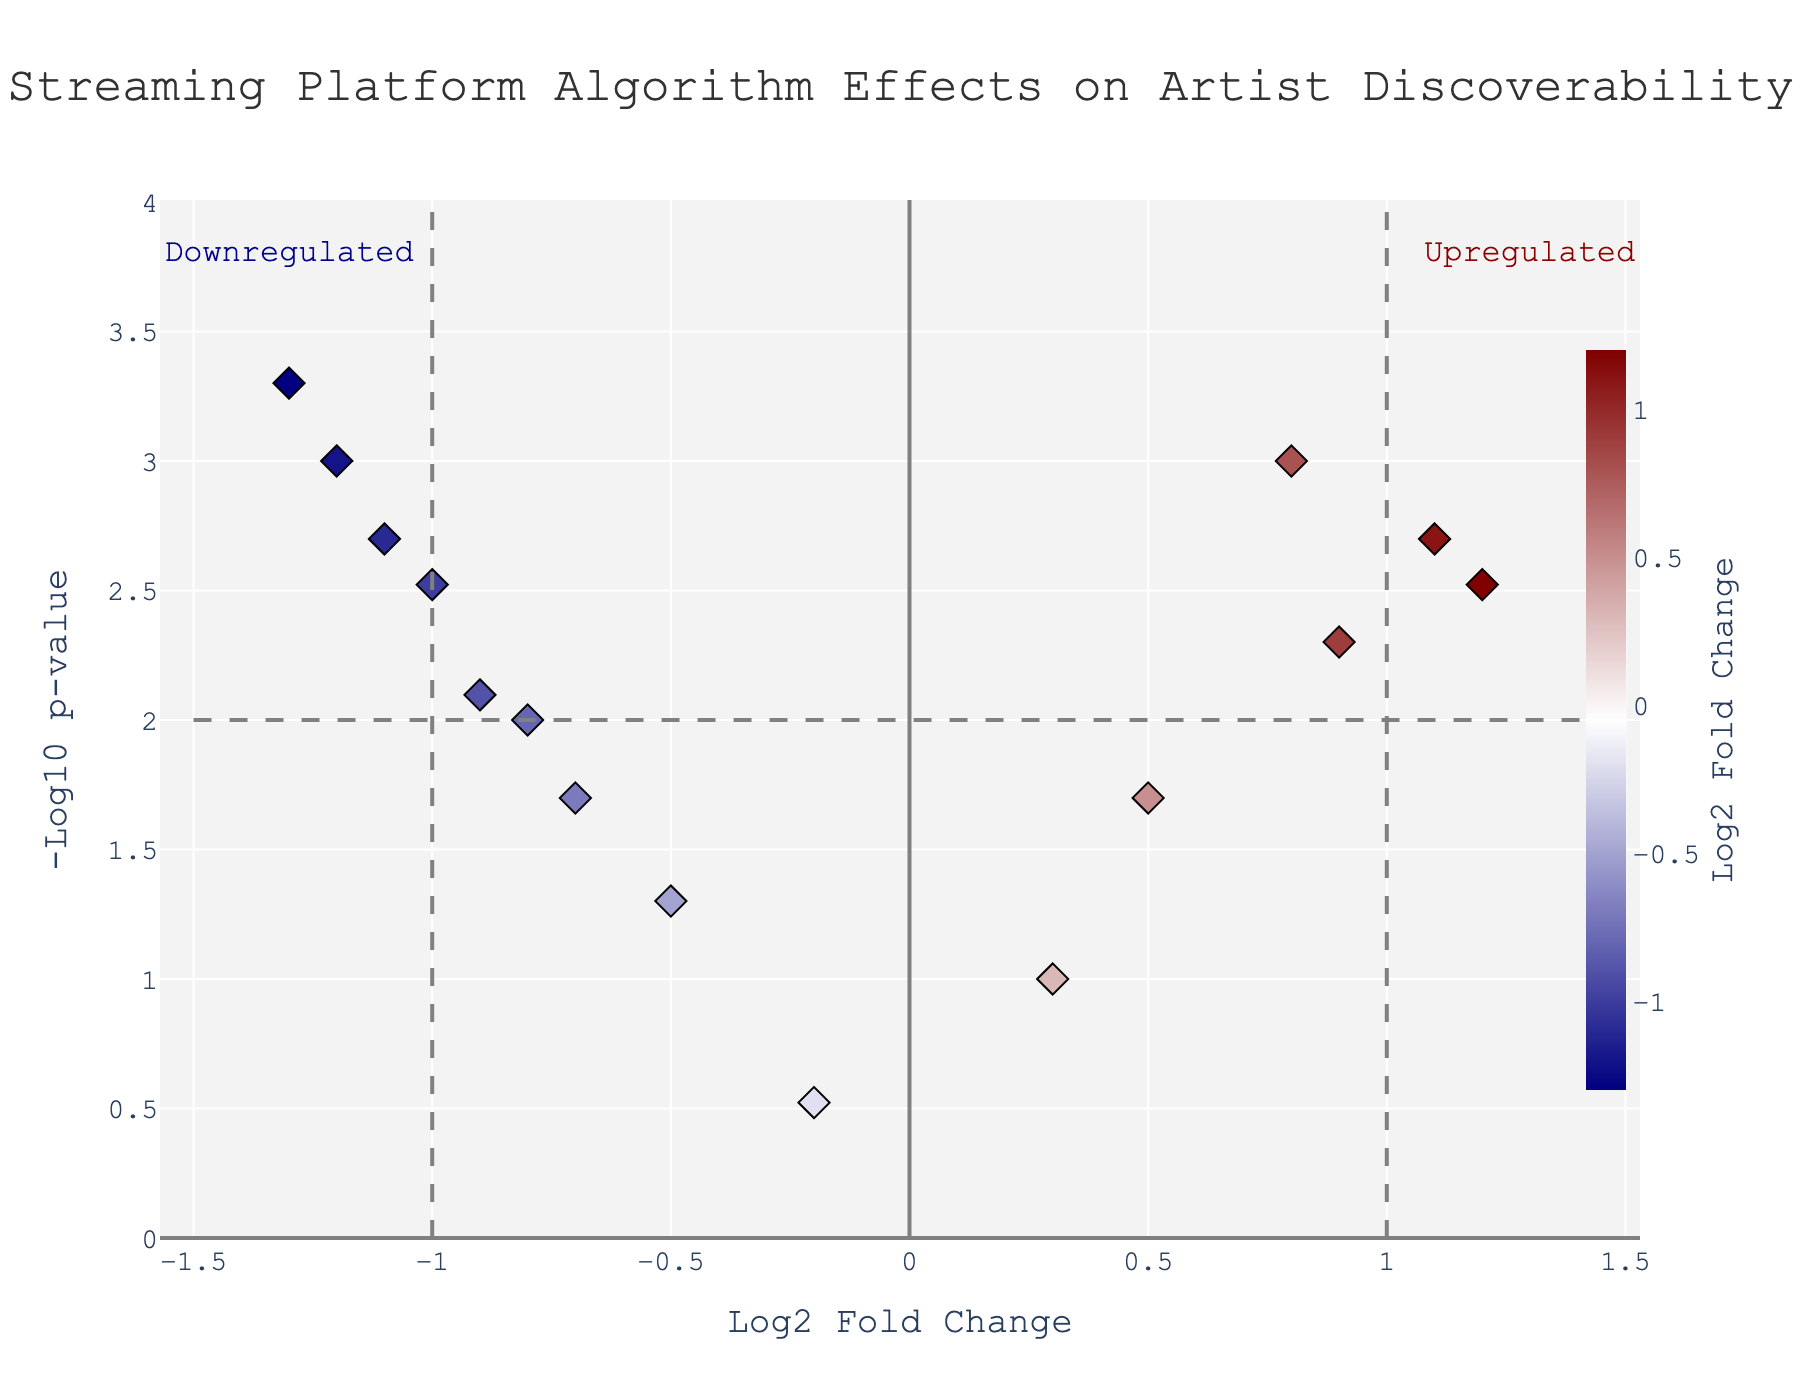what is the title of the figure? The title of the figure is typically displayed at the top center of the plot. From the description, the title given is 'Streaming Platform Algorithm Effects on Artist Discoverability'.
Answer: Streaming Platform Algorithm Effects on Artist Discoverability How many data points are there in the plot? The number of data points in a plot can be determined by counting the visually distinct points displayed. From the data provided, there are 14 artists, so there should be 14 data points.
Answer: 14 Which artist has the highest -log10 p-value on the plot? The highest -log10 p-value will appear as the topmost point on the y-axis. According to the data, Men I Trust has the highest -log10 p-value of 3.3010.
Answer: Men I Trust Which artists have a log2 fold change above 1? Artists with a log2 fold change above 1 will be situated to the right of the vertical line at x = 1. From the data, Billie Eilish and Olivia Rodrigo have log2 fold changes of 1.2 and 1.1, respectively.
Answer: Billie Eilish, Olivia Rodrigo Identify the artist with the most significant negative fold change. The most significant negative fold change would be the most leftward point on the x-axis, with the lowest log2 fold change. According to the data, Men I Trust has a log2 fold change of -1.3.
Answer: Men I Trust How many artists fall within the 'Upregulated' and 'Downregulated' categories? Artists classified as 'Upregulated' will be to the right of the vertical line at x = 1, and those classified as 'Downregulated' will be to the left of the vertical line at x = -1. Olivia Rodrigo and Billie Eilish are upregulated, and Phoebe Bridgers, Japanese Breakfast, Clairo, and Lucy Dacus are downregulated.
Answer: Upregulated: 2, Downregulated: 4 Which platform has the highest log2 fold change for mainstream artists? To find the platform with the highest log2 fold change, locate the highest rightward points with positive log2 fold change. Taylor Swift on Spotify has one of the highest log2 fold changes at 0.8.
Answer: Spotify Which indie artist shows a significant effect on Bandcamp? The significant effect at Bandcamp can be determined by significant placement within the plot, typically with a large -log10 p-value. According to data, Phoebe Bridgers on Bandcamp has a log2 fold change of -0.8 and a p-value of 0.01, making her significant.
Answer: Phoebe Bridgers 